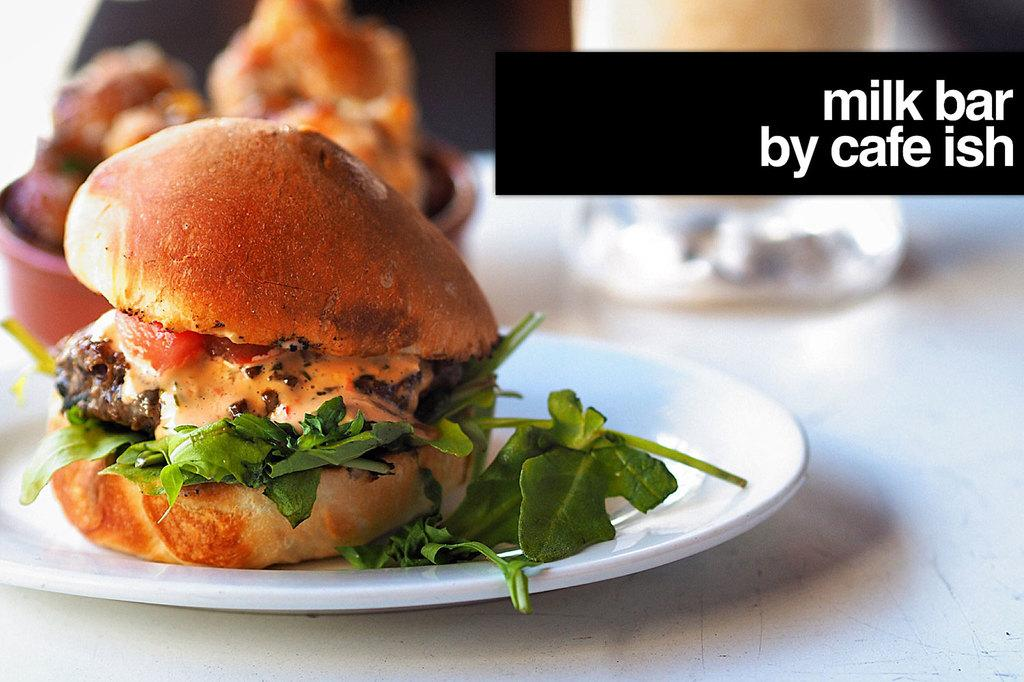What type of dishware can be seen in the image? There is a plate and a bowl in the image. What is present on these dishes? There is food in the image. Can you describe the object on the white platform? There is an object on a white platform, but the facts do not specify what it is. How would you describe the background of the image? The background of the image is blurry. Is there any additional information or branding present in the image? Yes, there is a watermark in the top right side of the image. How many pizzas are hanging from the cobweb in the image? There are no pizzas or cobwebs present in the image. What type of car is parked next to the object on the white platform? There is no car present in the image. 